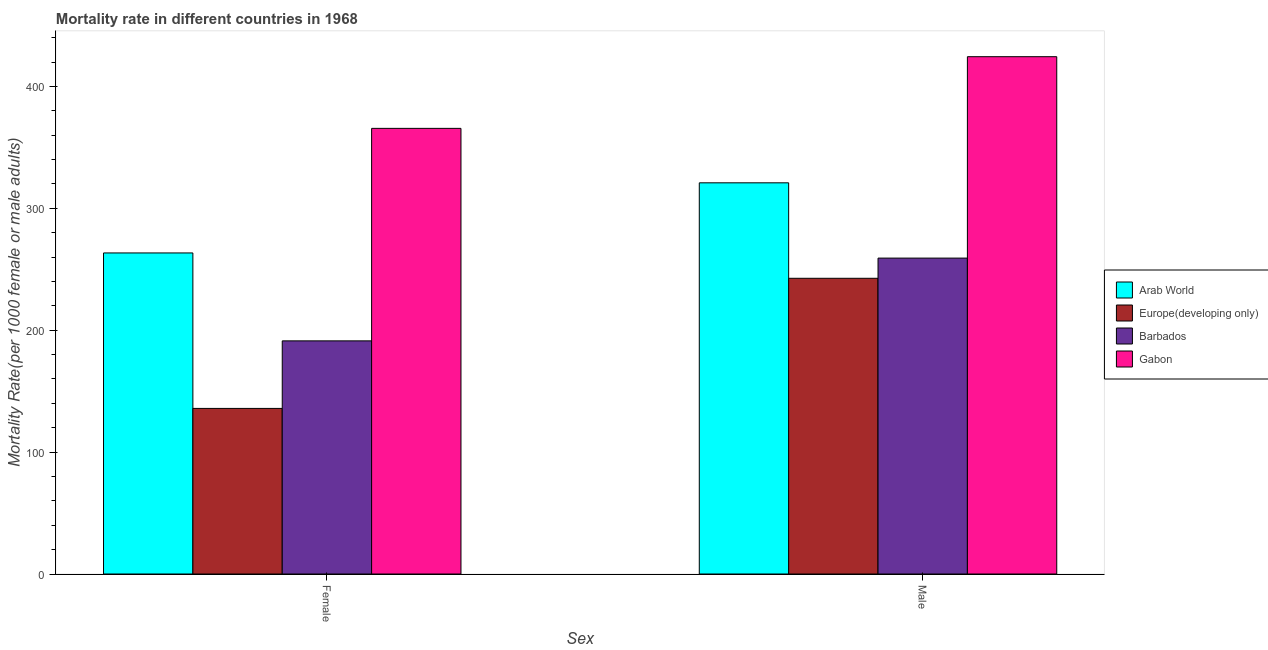How many different coloured bars are there?
Provide a short and direct response. 4. How many groups of bars are there?
Your answer should be very brief. 2. Are the number of bars per tick equal to the number of legend labels?
Your answer should be compact. Yes. How many bars are there on the 2nd tick from the left?
Ensure brevity in your answer.  4. How many bars are there on the 2nd tick from the right?
Make the answer very short. 4. What is the male mortality rate in Gabon?
Offer a very short reply. 424.43. Across all countries, what is the maximum female mortality rate?
Provide a succinct answer. 365.62. Across all countries, what is the minimum female mortality rate?
Ensure brevity in your answer.  135.86. In which country was the female mortality rate maximum?
Keep it short and to the point. Gabon. In which country was the female mortality rate minimum?
Your answer should be compact. Europe(developing only). What is the total male mortality rate in the graph?
Give a very brief answer. 1247.19. What is the difference between the male mortality rate in Barbados and that in Arab World?
Your answer should be compact. -61.77. What is the difference between the male mortality rate in Barbados and the female mortality rate in Europe(developing only)?
Offer a terse response. 123.33. What is the average male mortality rate per country?
Provide a short and direct response. 311.8. What is the difference between the male mortality rate and female mortality rate in Arab World?
Make the answer very short. 57.53. What is the ratio of the male mortality rate in Gabon to that in Barbados?
Offer a terse response. 1.64. Is the female mortality rate in Gabon less than that in Arab World?
Your answer should be very brief. No. In how many countries, is the female mortality rate greater than the average female mortality rate taken over all countries?
Make the answer very short. 2. What does the 2nd bar from the left in Male represents?
Keep it short and to the point. Europe(developing only). What does the 1st bar from the right in Male represents?
Provide a succinct answer. Gabon. Where does the legend appear in the graph?
Your response must be concise. Center right. How many legend labels are there?
Provide a succinct answer. 4. How are the legend labels stacked?
Offer a terse response. Vertical. What is the title of the graph?
Offer a terse response. Mortality rate in different countries in 1968. What is the label or title of the X-axis?
Offer a very short reply. Sex. What is the label or title of the Y-axis?
Your answer should be compact. Mortality Rate(per 1000 female or male adults). What is the Mortality Rate(per 1000 female or male adults) in Arab World in Female?
Your response must be concise. 263.42. What is the Mortality Rate(per 1000 female or male adults) in Europe(developing only) in Female?
Offer a very short reply. 135.86. What is the Mortality Rate(per 1000 female or male adults) of Barbados in Female?
Your response must be concise. 191.28. What is the Mortality Rate(per 1000 female or male adults) in Gabon in Female?
Give a very brief answer. 365.62. What is the Mortality Rate(per 1000 female or male adults) of Arab World in Male?
Offer a terse response. 320.95. What is the Mortality Rate(per 1000 female or male adults) in Europe(developing only) in Male?
Keep it short and to the point. 242.62. What is the Mortality Rate(per 1000 female or male adults) of Barbados in Male?
Keep it short and to the point. 259.18. What is the Mortality Rate(per 1000 female or male adults) of Gabon in Male?
Provide a succinct answer. 424.43. Across all Sex, what is the maximum Mortality Rate(per 1000 female or male adults) of Arab World?
Offer a terse response. 320.95. Across all Sex, what is the maximum Mortality Rate(per 1000 female or male adults) of Europe(developing only)?
Your response must be concise. 242.62. Across all Sex, what is the maximum Mortality Rate(per 1000 female or male adults) of Barbados?
Your answer should be compact. 259.18. Across all Sex, what is the maximum Mortality Rate(per 1000 female or male adults) in Gabon?
Offer a very short reply. 424.43. Across all Sex, what is the minimum Mortality Rate(per 1000 female or male adults) of Arab World?
Offer a terse response. 263.42. Across all Sex, what is the minimum Mortality Rate(per 1000 female or male adults) of Europe(developing only)?
Give a very brief answer. 135.86. Across all Sex, what is the minimum Mortality Rate(per 1000 female or male adults) of Barbados?
Your answer should be very brief. 191.28. Across all Sex, what is the minimum Mortality Rate(per 1000 female or male adults) in Gabon?
Offer a very short reply. 365.62. What is the total Mortality Rate(per 1000 female or male adults) of Arab World in the graph?
Your answer should be compact. 584.37. What is the total Mortality Rate(per 1000 female or male adults) of Europe(developing only) in the graph?
Offer a terse response. 378.48. What is the total Mortality Rate(per 1000 female or male adults) in Barbados in the graph?
Make the answer very short. 450.46. What is the total Mortality Rate(per 1000 female or male adults) in Gabon in the graph?
Your response must be concise. 790.05. What is the difference between the Mortality Rate(per 1000 female or male adults) in Arab World in Female and that in Male?
Give a very brief answer. -57.53. What is the difference between the Mortality Rate(per 1000 female or male adults) in Europe(developing only) in Female and that in Male?
Ensure brevity in your answer.  -106.76. What is the difference between the Mortality Rate(per 1000 female or male adults) in Barbados in Female and that in Male?
Your answer should be very brief. -67.9. What is the difference between the Mortality Rate(per 1000 female or male adults) of Gabon in Female and that in Male?
Keep it short and to the point. -58.81. What is the difference between the Mortality Rate(per 1000 female or male adults) in Arab World in Female and the Mortality Rate(per 1000 female or male adults) in Europe(developing only) in Male?
Offer a very short reply. 20.8. What is the difference between the Mortality Rate(per 1000 female or male adults) in Arab World in Female and the Mortality Rate(per 1000 female or male adults) in Barbados in Male?
Your response must be concise. 4.24. What is the difference between the Mortality Rate(per 1000 female or male adults) of Arab World in Female and the Mortality Rate(per 1000 female or male adults) of Gabon in Male?
Make the answer very short. -161.01. What is the difference between the Mortality Rate(per 1000 female or male adults) in Europe(developing only) in Female and the Mortality Rate(per 1000 female or male adults) in Barbados in Male?
Provide a succinct answer. -123.33. What is the difference between the Mortality Rate(per 1000 female or male adults) of Europe(developing only) in Female and the Mortality Rate(per 1000 female or male adults) of Gabon in Male?
Keep it short and to the point. -288.58. What is the difference between the Mortality Rate(per 1000 female or male adults) in Barbados in Female and the Mortality Rate(per 1000 female or male adults) in Gabon in Male?
Make the answer very short. -233.15. What is the average Mortality Rate(per 1000 female or male adults) of Arab World per Sex?
Provide a short and direct response. 292.19. What is the average Mortality Rate(per 1000 female or male adults) of Europe(developing only) per Sex?
Offer a terse response. 189.24. What is the average Mortality Rate(per 1000 female or male adults) of Barbados per Sex?
Offer a very short reply. 225.23. What is the average Mortality Rate(per 1000 female or male adults) of Gabon per Sex?
Offer a terse response. 395.03. What is the difference between the Mortality Rate(per 1000 female or male adults) of Arab World and Mortality Rate(per 1000 female or male adults) of Europe(developing only) in Female?
Give a very brief answer. 127.56. What is the difference between the Mortality Rate(per 1000 female or male adults) of Arab World and Mortality Rate(per 1000 female or male adults) of Barbados in Female?
Your answer should be compact. 72.14. What is the difference between the Mortality Rate(per 1000 female or male adults) of Arab World and Mortality Rate(per 1000 female or male adults) of Gabon in Female?
Offer a very short reply. -102.2. What is the difference between the Mortality Rate(per 1000 female or male adults) in Europe(developing only) and Mortality Rate(per 1000 female or male adults) in Barbados in Female?
Offer a terse response. -55.42. What is the difference between the Mortality Rate(per 1000 female or male adults) in Europe(developing only) and Mortality Rate(per 1000 female or male adults) in Gabon in Female?
Your answer should be very brief. -229.76. What is the difference between the Mortality Rate(per 1000 female or male adults) of Barbados and Mortality Rate(per 1000 female or male adults) of Gabon in Female?
Offer a very short reply. -174.34. What is the difference between the Mortality Rate(per 1000 female or male adults) in Arab World and Mortality Rate(per 1000 female or male adults) in Europe(developing only) in Male?
Keep it short and to the point. 78.33. What is the difference between the Mortality Rate(per 1000 female or male adults) of Arab World and Mortality Rate(per 1000 female or male adults) of Barbados in Male?
Make the answer very short. 61.77. What is the difference between the Mortality Rate(per 1000 female or male adults) in Arab World and Mortality Rate(per 1000 female or male adults) in Gabon in Male?
Your answer should be compact. -103.48. What is the difference between the Mortality Rate(per 1000 female or male adults) in Europe(developing only) and Mortality Rate(per 1000 female or male adults) in Barbados in Male?
Offer a very short reply. -16.56. What is the difference between the Mortality Rate(per 1000 female or male adults) in Europe(developing only) and Mortality Rate(per 1000 female or male adults) in Gabon in Male?
Keep it short and to the point. -181.81. What is the difference between the Mortality Rate(per 1000 female or male adults) of Barbados and Mortality Rate(per 1000 female or male adults) of Gabon in Male?
Offer a terse response. -165.25. What is the ratio of the Mortality Rate(per 1000 female or male adults) in Arab World in Female to that in Male?
Provide a succinct answer. 0.82. What is the ratio of the Mortality Rate(per 1000 female or male adults) in Europe(developing only) in Female to that in Male?
Offer a very short reply. 0.56. What is the ratio of the Mortality Rate(per 1000 female or male adults) of Barbados in Female to that in Male?
Your response must be concise. 0.74. What is the ratio of the Mortality Rate(per 1000 female or male adults) in Gabon in Female to that in Male?
Provide a succinct answer. 0.86. What is the difference between the highest and the second highest Mortality Rate(per 1000 female or male adults) in Arab World?
Keep it short and to the point. 57.53. What is the difference between the highest and the second highest Mortality Rate(per 1000 female or male adults) of Europe(developing only)?
Your answer should be compact. 106.76. What is the difference between the highest and the second highest Mortality Rate(per 1000 female or male adults) in Barbados?
Make the answer very short. 67.9. What is the difference between the highest and the second highest Mortality Rate(per 1000 female or male adults) in Gabon?
Keep it short and to the point. 58.81. What is the difference between the highest and the lowest Mortality Rate(per 1000 female or male adults) of Arab World?
Give a very brief answer. 57.53. What is the difference between the highest and the lowest Mortality Rate(per 1000 female or male adults) in Europe(developing only)?
Your response must be concise. 106.76. What is the difference between the highest and the lowest Mortality Rate(per 1000 female or male adults) in Barbados?
Offer a very short reply. 67.9. What is the difference between the highest and the lowest Mortality Rate(per 1000 female or male adults) in Gabon?
Make the answer very short. 58.81. 